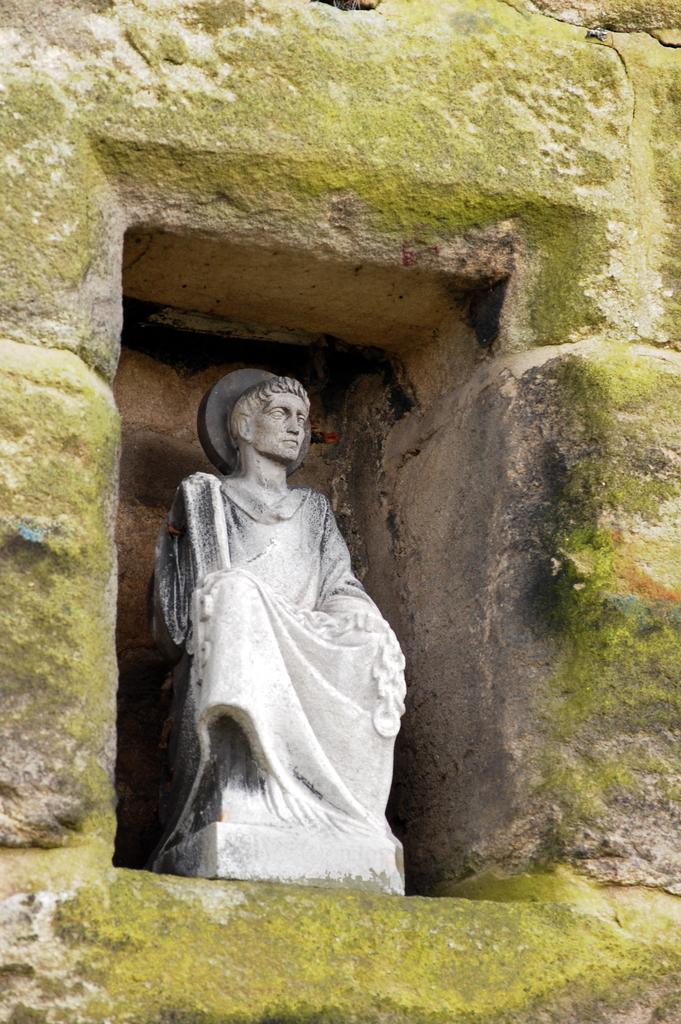Could you give a brief overview of what you see in this image? In this picture there is a statue on the wall. 